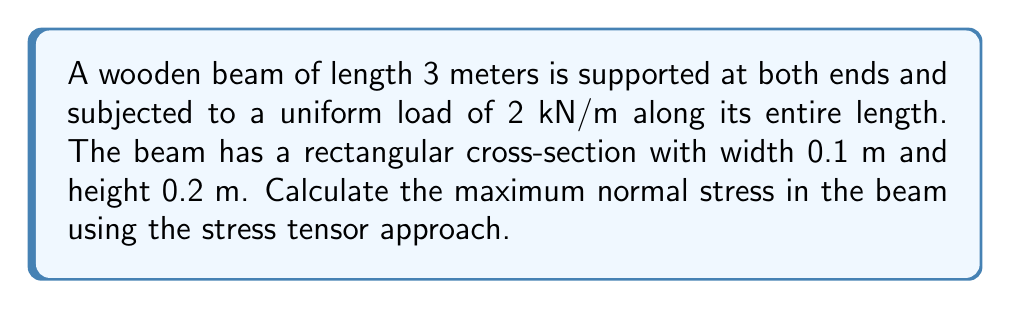Can you answer this question? 1. First, we need to calculate the maximum bending moment:
   $$M_{max} = \frac{wL^2}{8}$$
   where $w$ is the uniform load and $L$ is the length of the beam.
   $$M_{max} = \frac{2 \text{ kN/m} \times (3 \text{ m})^2}{8} = 2.25 \text{ kN}\cdot\text{m}$$

2. Next, calculate the moment of inertia for the rectangular cross-section:
   $$I = \frac{bh^3}{12}$$
   where $b$ is the width and $h$ is the height of the beam.
   $$I = \frac{0.1 \text{ m} \times (0.2 \text{ m})^3}{12} = 6.67 \times 10^{-5} \text{ m}^4$$

3. The stress tensor for a beam under bending is:
   $$\sigma = \begin{bmatrix}
   \sigma_{xx} & 0 & 0 \\
   0 & 0 & 0 \\
   0 & 0 & 0
   \end{bmatrix}$$

   where $\sigma_{xx}$ is the normal stress given by:
   $$\sigma_{xx} = \frac{My}{I}$$
   
   $y$ is the distance from the neutral axis, which is maximum at the top or bottom surface of the beam: $y = \pm h/2 = \pm 0.1 \text{ m}$

4. Calculate the maximum normal stress:
   $$\sigma_{xx,max} = \frac{M_{max}y_{max}}{I} = \frac{2250 \text{ N}\cdot\text{m} \times 0.1 \text{ m}}{6.67 \times 10^{-5} \text{ m}^4} = 3.37 \times 10^6 \text{ Pa} = 3.37 \text{ MPa}$$

5. Therefore, the stress tensor at the point of maximum stress is:
   $$\sigma_{max} = \begin{bmatrix}
   3.37 \times 10^6 & 0 & 0 \\
   0 & 0 & 0 \\
   0 & 0 & 0
   \end{bmatrix} \text{ Pa}$$
Answer: $$\sigma_{max} = \begin{bmatrix}
3.37 \times 10^6 & 0 & 0 \\
0 & 0 & 0 \\
0 & 0 & 0
\end{bmatrix} \text{ Pa}$$ 